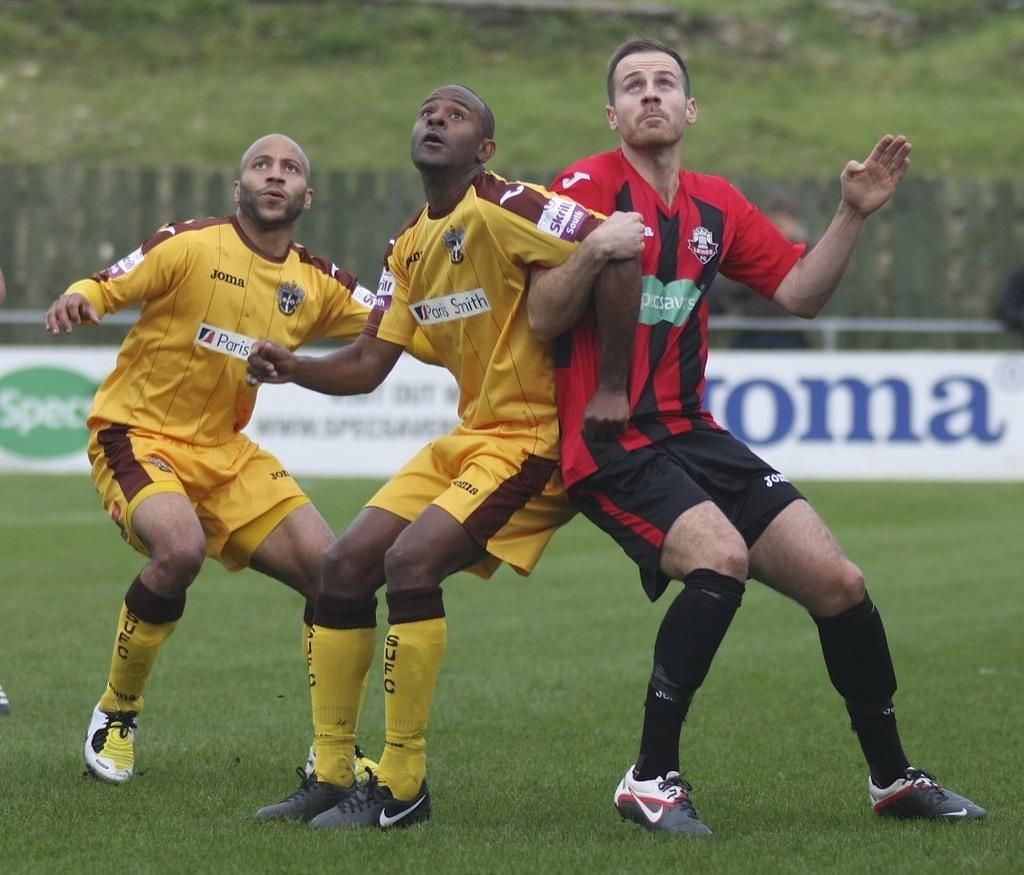<image>
Relay a brief, clear account of the picture shown. A team of players are from Paris  Smith. 